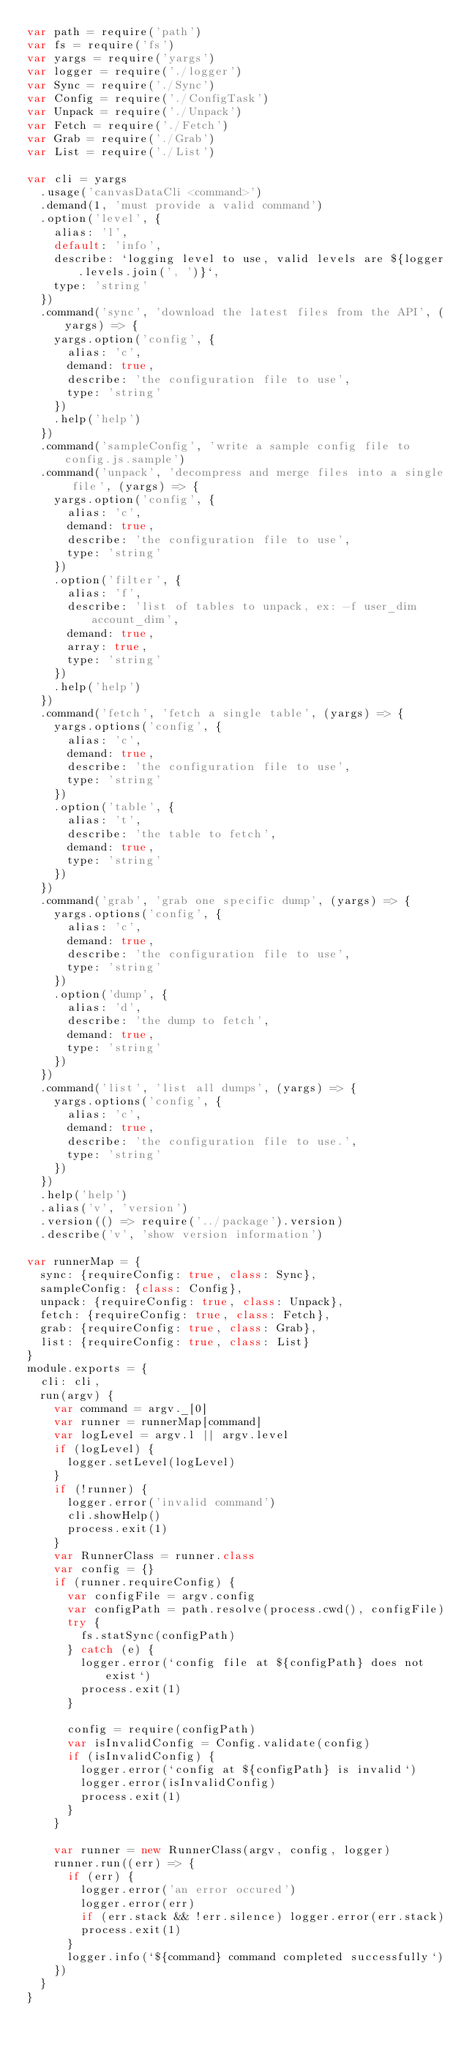<code> <loc_0><loc_0><loc_500><loc_500><_JavaScript_>var path = require('path')
var fs = require('fs')
var yargs = require('yargs')
var logger = require('./logger')
var Sync = require('./Sync')
var Config = require('./ConfigTask')
var Unpack = require('./Unpack')
var Fetch = require('./Fetch')
var Grab = require('./Grab')
var List = require('./List')

var cli = yargs
  .usage('canvasDataCli <command>')
  .demand(1, 'must provide a valid command')
  .option('level', {
    alias: 'l',
    default: 'info',
    describe: `logging level to use, valid levels are ${logger.levels.join(', ')}`,
    type: 'string'
  })
  .command('sync', 'download the latest files from the API', (yargs) => {
    yargs.option('config', {
      alias: 'c',
      demand: true,
      describe: 'the configuration file to use',
      type: 'string'
    })
    .help('help')
  })
  .command('sampleConfig', 'write a sample config file to config.js.sample')
  .command('unpack', 'decompress and merge files into a single file', (yargs) => {
    yargs.option('config', {
      alias: 'c',
      demand: true,
      describe: 'the configuration file to use',
      type: 'string'
    })
    .option('filter', {
      alias: 'f',
      describe: 'list of tables to unpack, ex: -f user_dim account_dim',
      demand: true,
      array: true,
      type: 'string'
    })
    .help('help')
  })
  .command('fetch', 'fetch a single table', (yargs) => {
    yargs.options('config', {
      alias: 'c',
      demand: true,
      describe: 'the configuration file to use',
      type: 'string'
    })
    .option('table', {
      alias: 't',
      describe: 'the table to fetch',
      demand: true,
      type: 'string'
    })
  })
  .command('grab', 'grab one specific dump', (yargs) => {
    yargs.options('config', {
      alias: 'c',
      demand: true,
      describe: 'the configuration file to use',
      type: 'string'
    })
    .option('dump', {
      alias: 'd',
      describe: 'the dump to fetch',
      demand: true,
      type: 'string'
    })
  })
  .command('list', 'list all dumps', (yargs) => {
    yargs.options('config', {
      alias: 'c',
      demand: true,
      describe: 'the configuration file to use.',
      type: 'string'
    })
  })
  .help('help')
  .alias('v', 'version')
  .version(() => require('../package').version)
  .describe('v', 'show version information')

var runnerMap = {
  sync: {requireConfig: true, class: Sync},
  sampleConfig: {class: Config},
  unpack: {requireConfig: true, class: Unpack},
  fetch: {requireConfig: true, class: Fetch},
  grab: {requireConfig: true, class: Grab},
  list: {requireConfig: true, class: List}
}
module.exports = {
  cli: cli,
  run(argv) {
    var command = argv._[0]
    var runner = runnerMap[command]
    var logLevel = argv.l || argv.level
    if (logLevel) {
      logger.setLevel(logLevel)
    }
    if (!runner) {
      logger.error('invalid command')
      cli.showHelp()
      process.exit(1)
    }
    var RunnerClass = runner.class
    var config = {}
    if (runner.requireConfig) {
      var configFile = argv.config
      var configPath = path.resolve(process.cwd(), configFile)
      try {
        fs.statSync(configPath)
      } catch (e) {
        logger.error(`config file at ${configPath} does not exist`)
        process.exit(1)
      }

      config = require(configPath)
      var isInvalidConfig = Config.validate(config)
      if (isInvalidConfig) {
        logger.error(`config at ${configPath} is invalid`)
        logger.error(isInvalidConfig)
        process.exit(1)
      }
    }

    var runner = new RunnerClass(argv, config, logger)
    runner.run((err) => {
      if (err) {
        logger.error('an error occured')
        logger.error(err)
        if (err.stack && !err.silence) logger.error(err.stack)
        process.exit(1)
      }
      logger.info(`${command} command completed successfully`)
    })
  }
}
</code> 